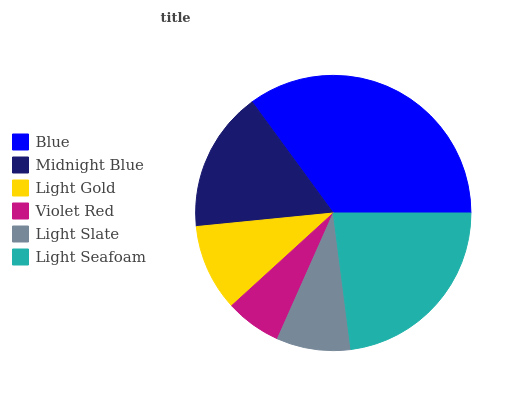Is Violet Red the minimum?
Answer yes or no. Yes. Is Blue the maximum?
Answer yes or no. Yes. Is Midnight Blue the minimum?
Answer yes or no. No. Is Midnight Blue the maximum?
Answer yes or no. No. Is Blue greater than Midnight Blue?
Answer yes or no. Yes. Is Midnight Blue less than Blue?
Answer yes or no. Yes. Is Midnight Blue greater than Blue?
Answer yes or no. No. Is Blue less than Midnight Blue?
Answer yes or no. No. Is Midnight Blue the high median?
Answer yes or no. Yes. Is Light Gold the low median?
Answer yes or no. Yes. Is Light Gold the high median?
Answer yes or no. No. Is Violet Red the low median?
Answer yes or no. No. 